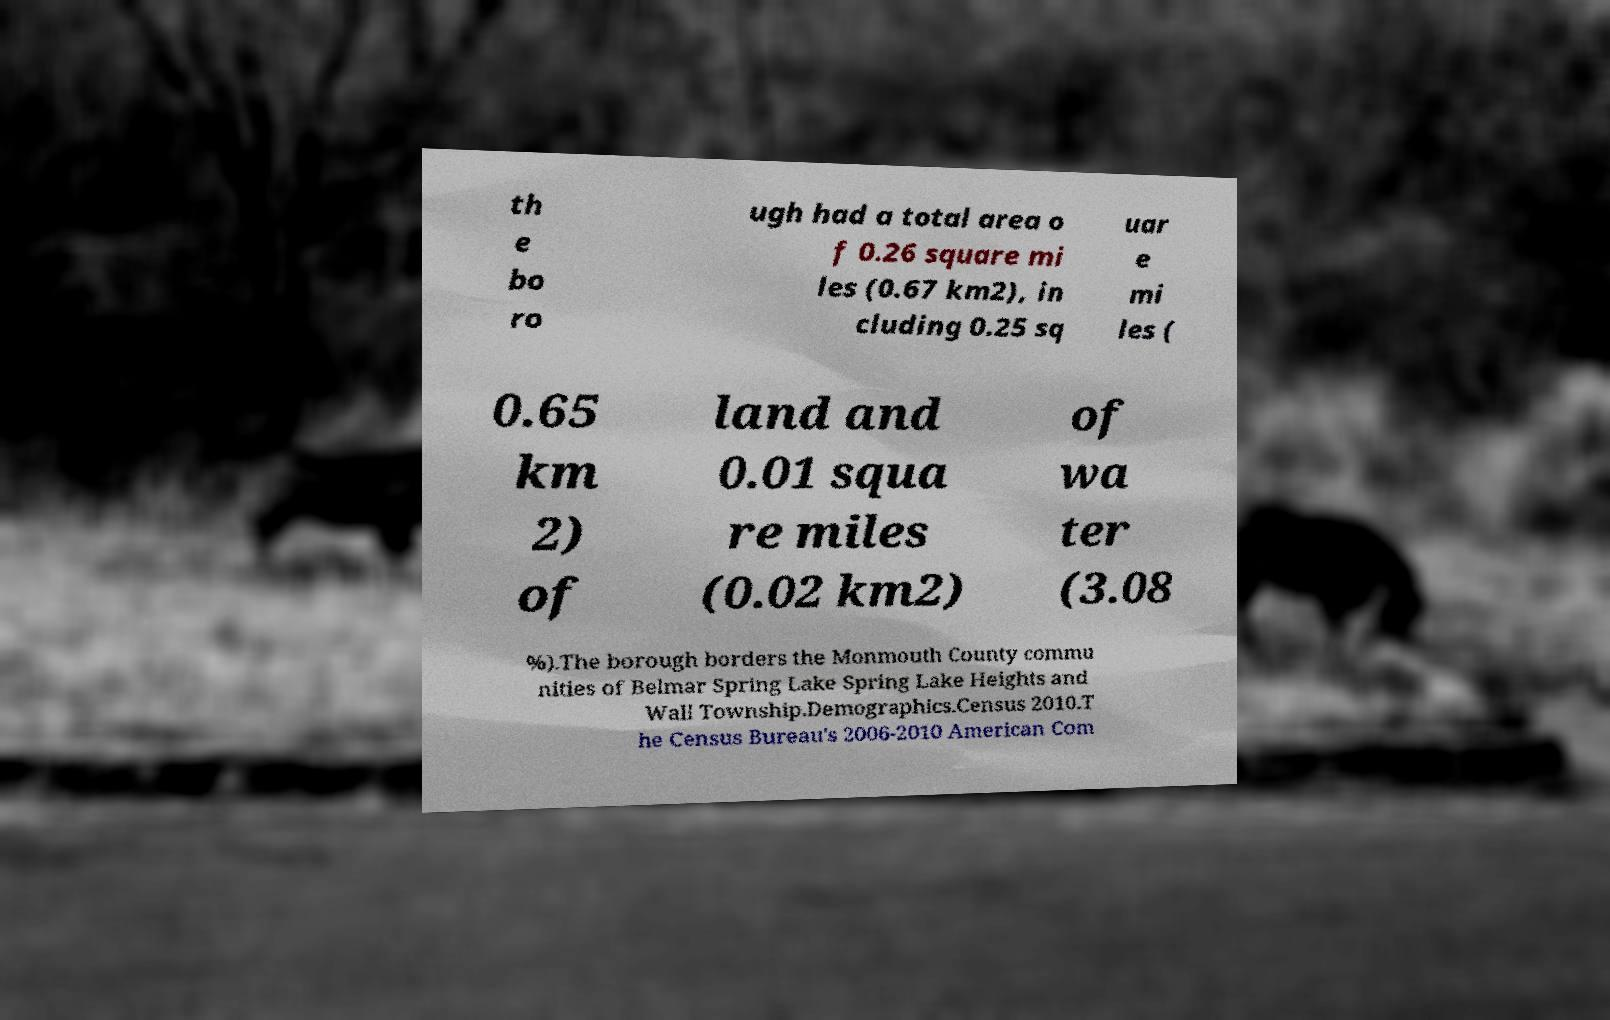What messages or text are displayed in this image? I need them in a readable, typed format. th e bo ro ugh had a total area o f 0.26 square mi les (0.67 km2), in cluding 0.25 sq uar e mi les ( 0.65 km 2) of land and 0.01 squa re miles (0.02 km2) of wa ter (3.08 %).The borough borders the Monmouth County commu nities of Belmar Spring Lake Spring Lake Heights and Wall Township.Demographics.Census 2010.T he Census Bureau's 2006-2010 American Com 